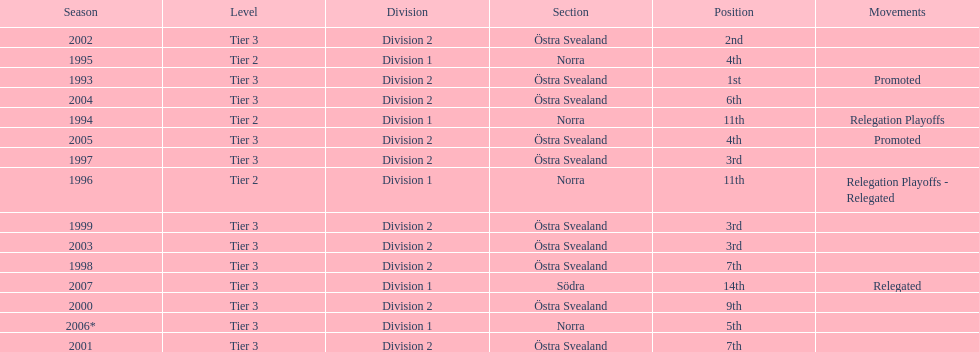How many times did they finish above 5th place in division 2 tier 3? 6. 